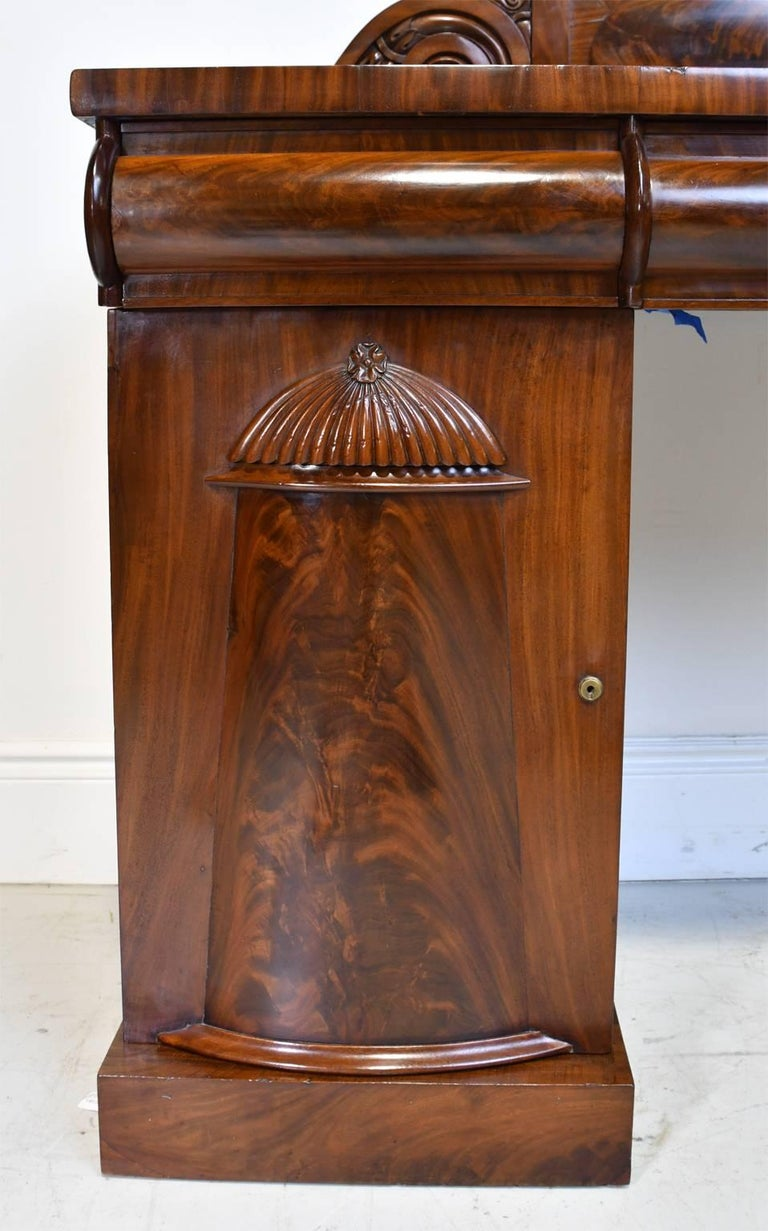What type of furniture does this section belong to, and what are its potential uses? This image features a section of a traditional wooden pedestal desk characterized by its elegant walnut finish and detailed woodwork. The prominent carved shell motif and the smooth, rolled edge are indicative of a refined craftsmanship often found in 18th-century English furniture. This particular section houses a keyhole, suggesting it could be a lockable drawer intended for securing important documents, personal correspondence, or other private items. Additionally, such a drawer is not only functional but also adds aesthetic value, making it a sophisticated piece for any office setting. 